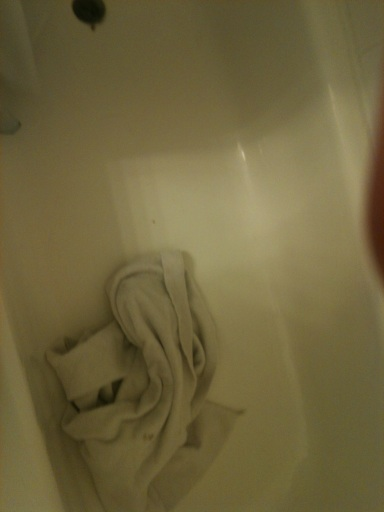What is the object in the bathtub and should it be there? The object in the bathtub is a towel. It should ideally not be there if assessing cleanliness, as it suggests the bathtub might need cleaning or that it’s being used for laundry purposes. 